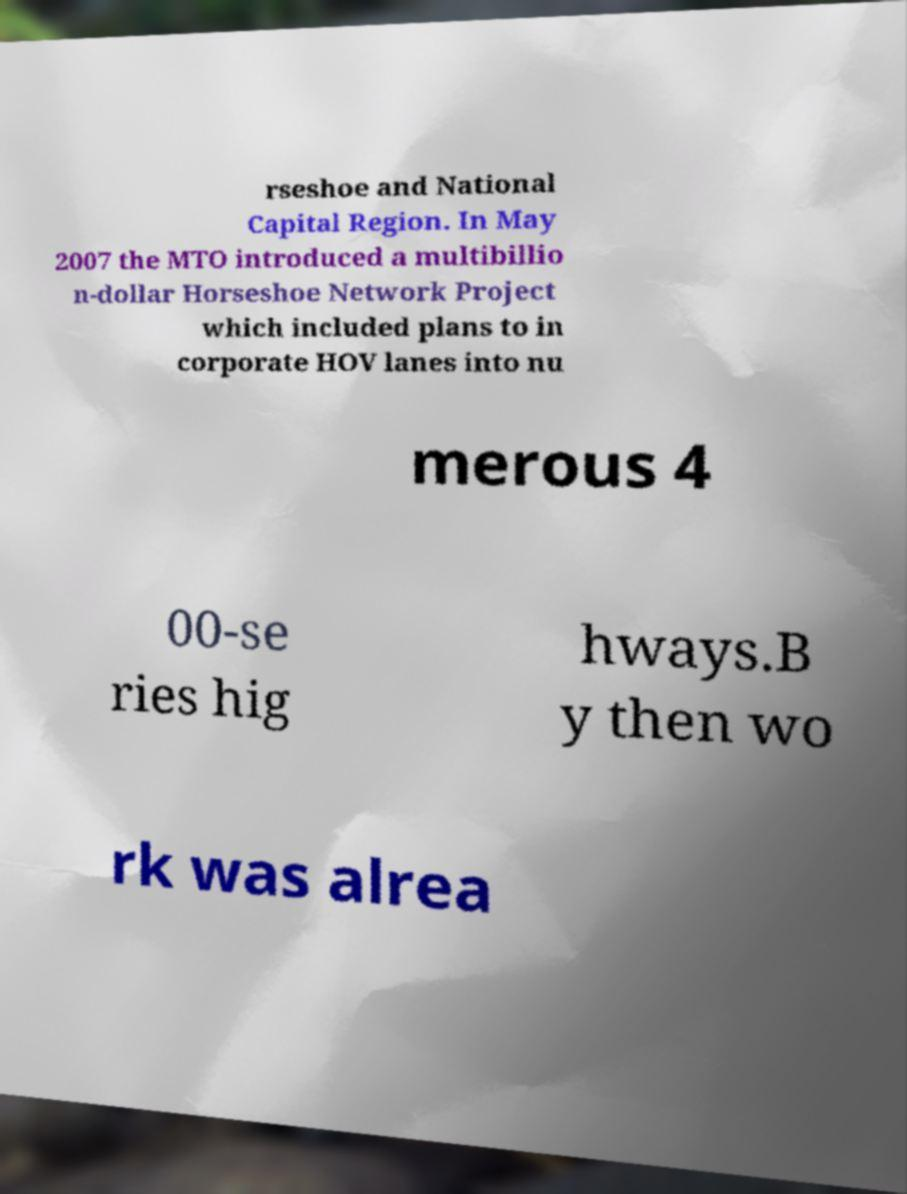Please read and relay the text visible in this image. What does it say? rseshoe and National Capital Region. In May 2007 the MTO introduced a multibillio n-dollar Horseshoe Network Project which included plans to in corporate HOV lanes into nu merous 4 00-se ries hig hways.B y then wo rk was alrea 